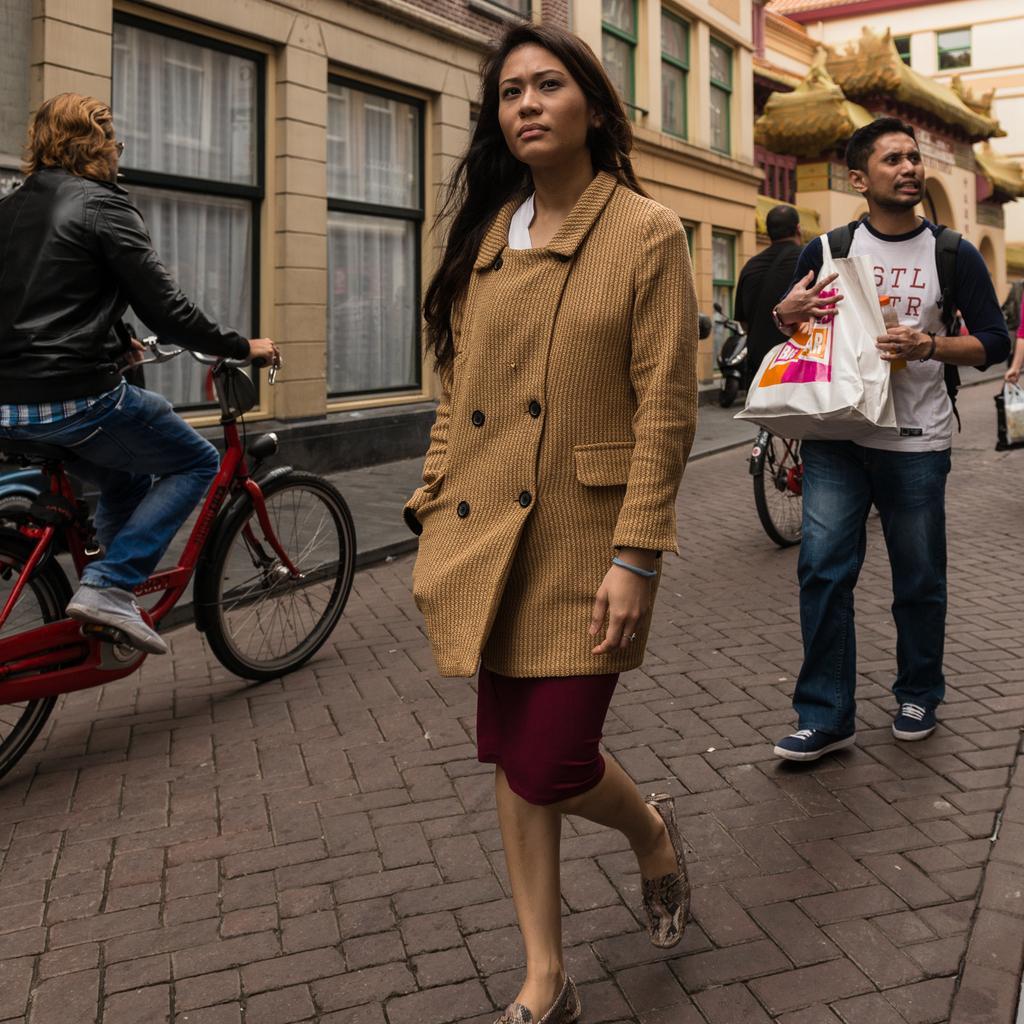How would you summarize this image in a sentence or two? In this picture we can see a woman and a man walking on the road. And here we can see two persons on the bicycle. And this is the building. 